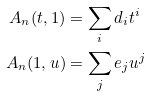Convert formula to latex. <formula><loc_0><loc_0><loc_500><loc_500>A _ { n } ( t , 1 ) & = \sum _ { i } d _ { i } t ^ { i } \\ A _ { n } ( 1 , u ) & = \sum _ { j } e _ { j } u ^ { j }</formula> 